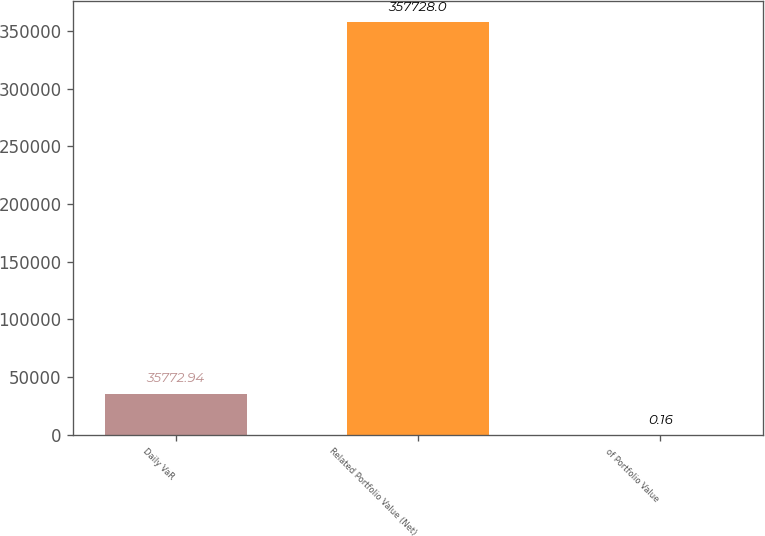Convert chart. <chart><loc_0><loc_0><loc_500><loc_500><bar_chart><fcel>Daily VaR<fcel>Related Portfolio Value (Net)<fcel>of Portfolio Value<nl><fcel>35772.9<fcel>357728<fcel>0.16<nl></chart> 